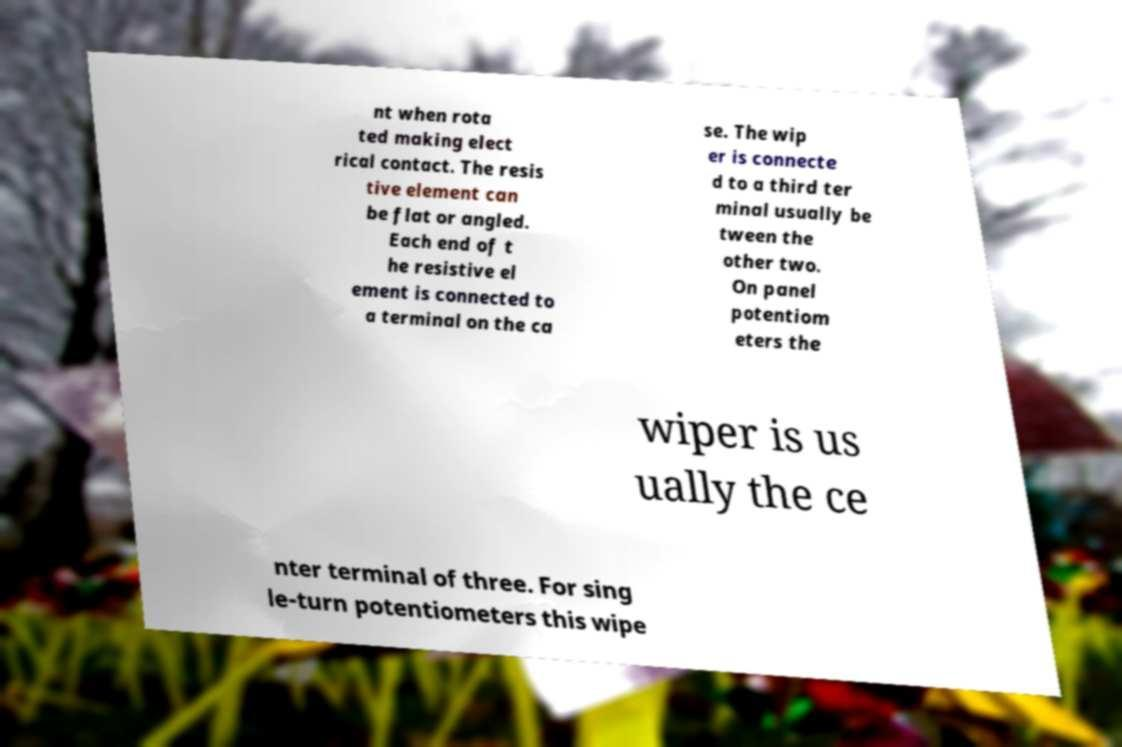Could you extract and type out the text from this image? nt when rota ted making elect rical contact. The resis tive element can be flat or angled. Each end of t he resistive el ement is connected to a terminal on the ca se. The wip er is connecte d to a third ter minal usually be tween the other two. On panel potentiom eters the wiper is us ually the ce nter terminal of three. For sing le-turn potentiometers this wipe 